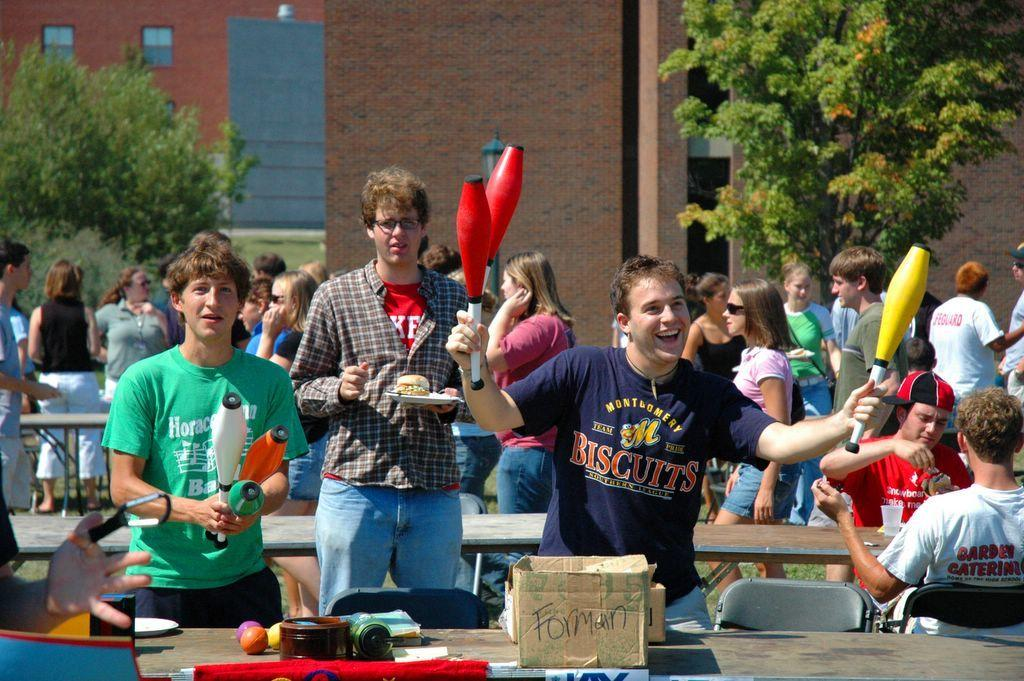<image>
Create a compact narrative representing the image presented. A happy juggler is wearing a blue T shirt which reads Montgomery Biscuits. 